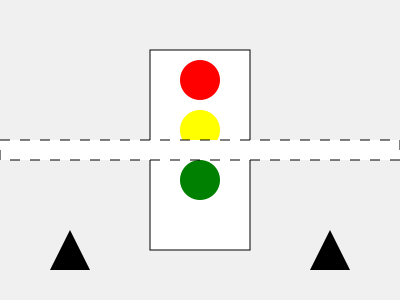Which of the following actions should students be instructed to take when encountering the traffic signal and crosswalk configuration shown in the image?

A) Cross immediately
B) Wait for the green light, then cross
C) Cross only if no cars are visible
D) Never cross at this intersection To determine the correct action for students, let's analyze the image step-by-step:

1. The image shows a standard traffic light with red, yellow, and green signals.
2. Below the traffic light, there's a marked crosswalk indicated by white stripes on the road.
3. On both sides of the crosswalk, there are triangular signs, which typically represent pedestrian crossing warnings for drivers.

Given this configuration:

1. The presence of a traffic light and a marked crosswalk indicates that this is a designated crossing point for pedestrians.
2. The traffic light is controlling both vehicular and pedestrian traffic.
3. As a safety measure, students should be instructed to:
   a) Stop at the crosswalk
   b) Wait for the traffic light to turn green
   c) Look both ways to ensure all vehicles have stopped
   d) Cross within the marked crosswalk area

Therefore, the correct action is to wait for the green light and then cross. This ensures that students are crossing when they have the right of way, maximizing their safety.

Option A (cross immediately) is dangerous as it disregards the traffic signal.
Option C (cross if no cars are visible) is also unsafe as it doesn't account for the traffic signal or potential approaching vehicles.
Option D (never cross) is incorrect as this is clearly a designated crossing point.
Answer: B) Wait for the green light, then cross 